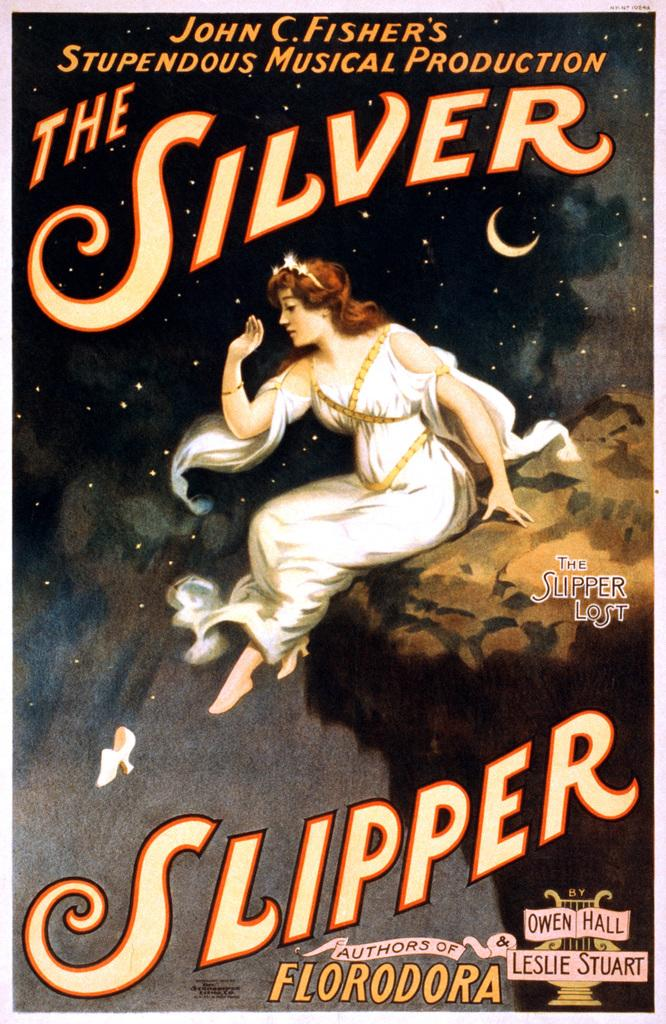<image>
Present a compact description of the photo's key features. a poster that says 'the silver slipper' on it 